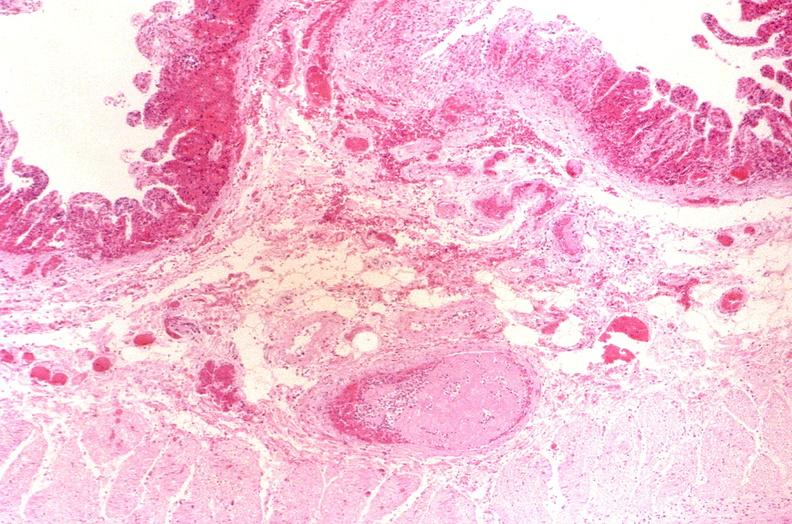where is this from?
Answer the question using a single word or phrase. Gastrointestinal system 